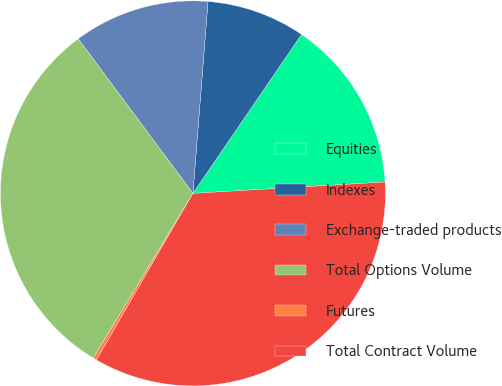Convert chart to OTSL. <chart><loc_0><loc_0><loc_500><loc_500><pie_chart><fcel>Equities<fcel>Indexes<fcel>Exchange-traded products<fcel>Total Options Volume<fcel>Futures<fcel>Total Contract Volume<nl><fcel>14.52%<fcel>8.29%<fcel>11.41%<fcel>31.17%<fcel>0.31%<fcel>34.29%<nl></chart> 